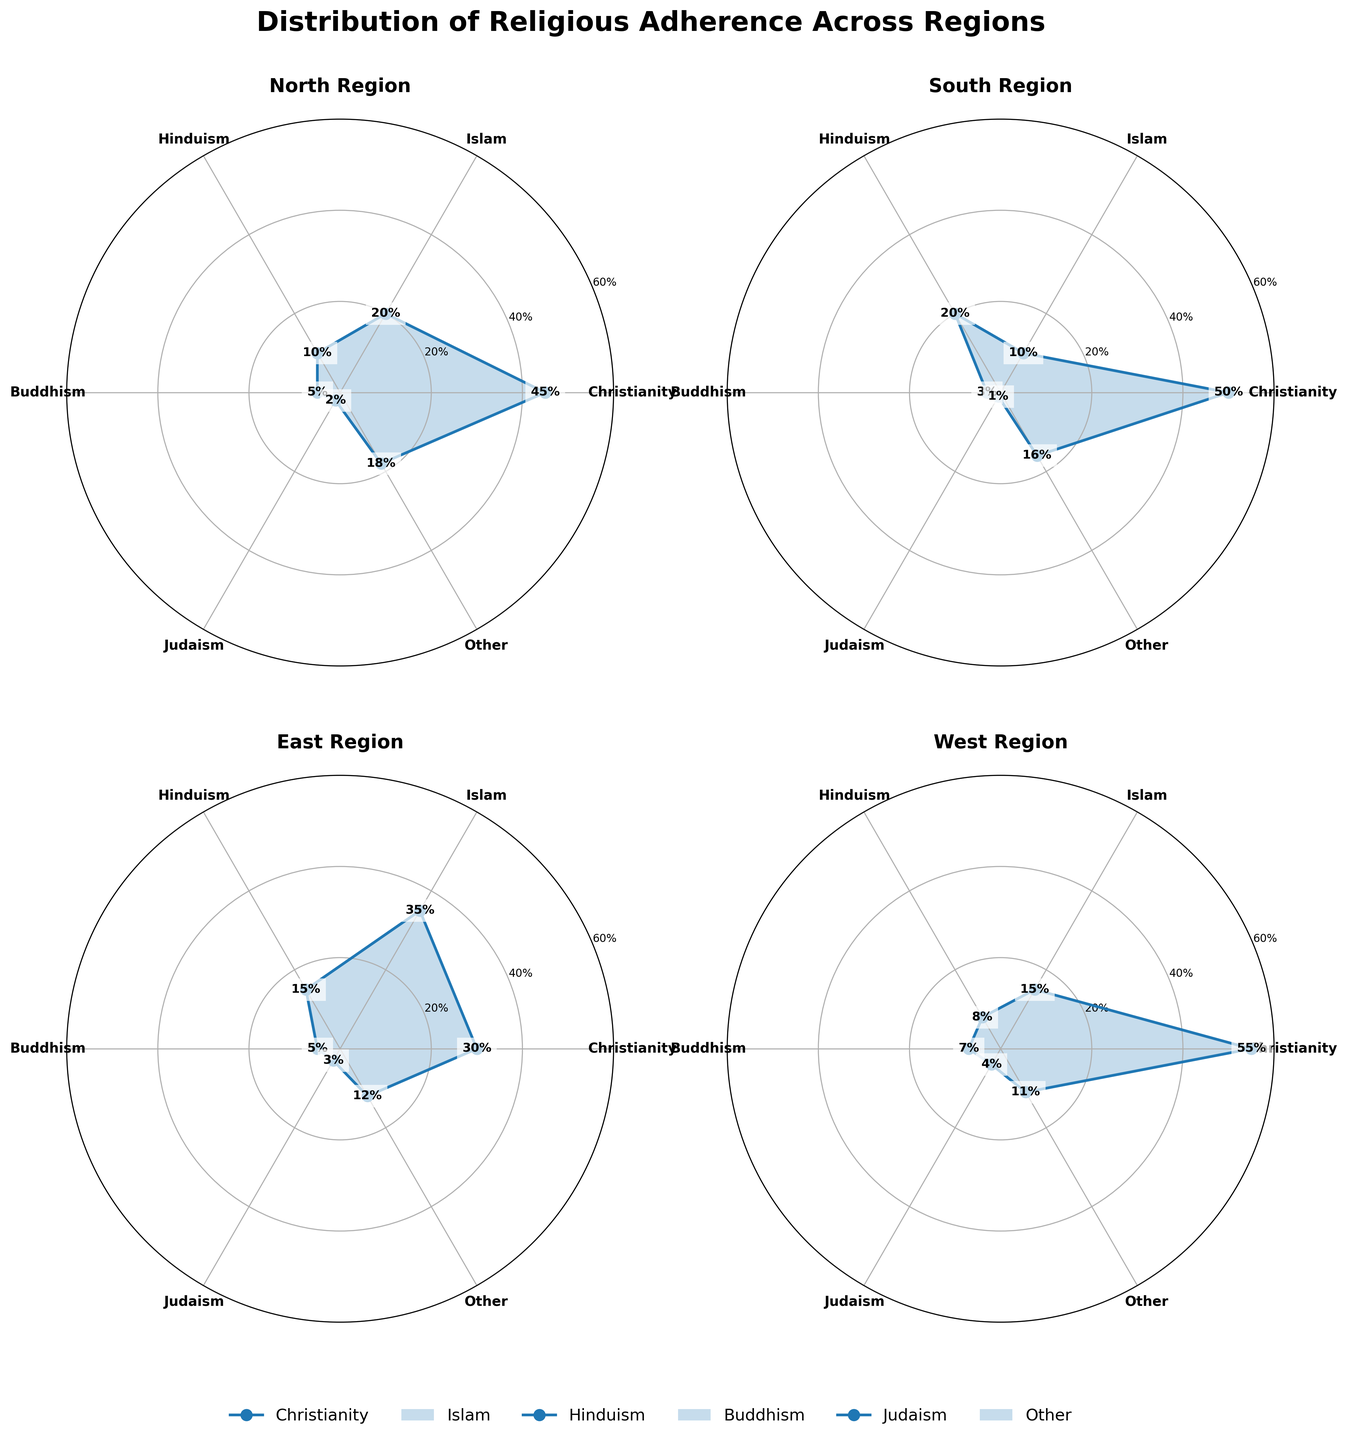What is the title of the figure? The title of the figure is displayed at the top and summarizes the main content. It reads, "Distribution of Religious Adherence Across Regions".
Answer: Distribution of Religious Adherence Across Regions Which region has the highest percentage of Christianity adherence? Look at the radial labels and the filled areas for the "Christianity" segment in each rose chart. The West region has the highest at 55%.
Answer: West What is the combined percentage of Hinduism adherence in all regions? Sum the percentages of Hinduism adherence in North (10), South (20), East (15), and West (8). So, 10 + 20 + 15 + 8 = 53.
Answer: 53% Which two regions have the highest adherence to Islam? Look at the radial labels and the filled areas for the "Islam" segment. East has 35%, and North has 20%.
Answer: East and North Is there any region where Buddhism adherence is higher than 10%? Check the radial labels and the filled areas for "Buddhism" in all regions. No region has Buddhism adherence higher than 10%. The highest is 7% in the West.
Answer: No Which region has the smallest percentage of adherence to Judaism? Observe the "Judaism" segment in each rose chart. The South region has the smallest at 1%.
Answer: South Compare the adherence to 'Other' religions between North and South. Which is greater and by how much? North has 18% adherence to "Other" and South has 16%. The difference is 18% - 16% = 2%.
Answer: North; by 2% How much more percentage of the population adheres to Christianity than Islam in the South region? In the South, Christianity adherence is 50% and Islam is 10%. The difference is 50% - 10% = 40%.
Answer: 40% Which region has the most balanced distribution of religious adherence, considering the major faiths? Balance in adherence can be interpreted by the evenness of the filled areas in the rose chart. The East region appears most balanced as no single faith overly dominates and all percentages are closer to each other.
Answer: East 